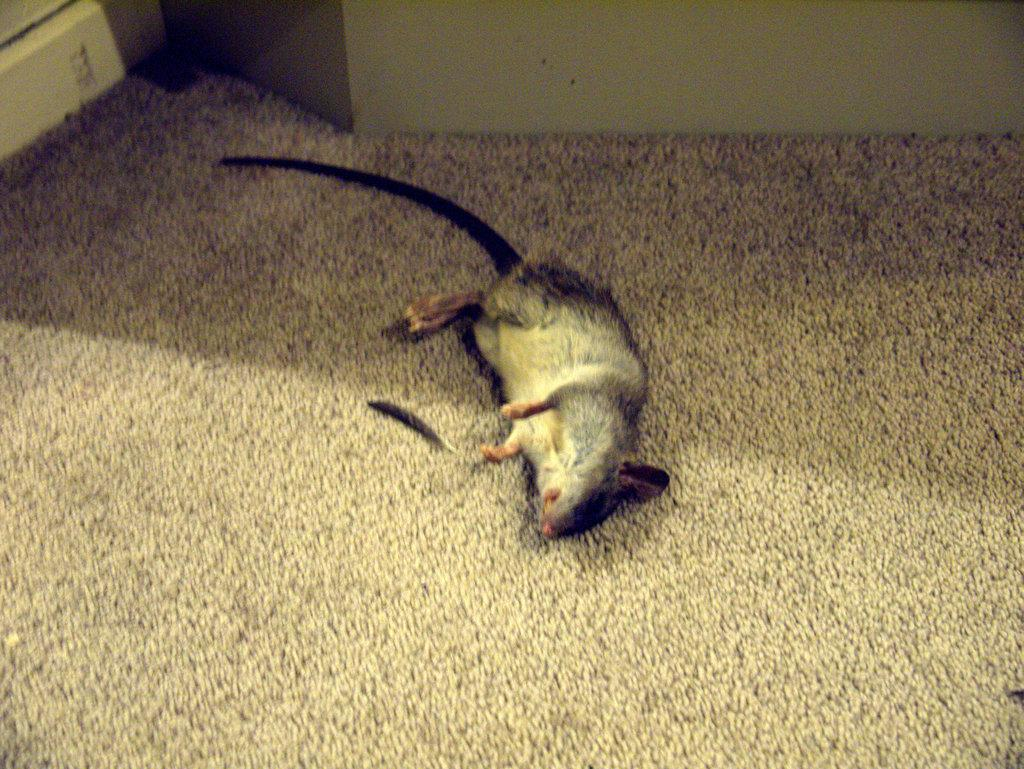What animal is in the picture? There is a mouse in the picture. What position is the mouse in? The mouse is lying on the ground. What can be seen in the background of the picture? There is a wall in the background of the picture. What type of cream is the mouse using to taste the wall in the image? There is no cream present in the image, and the mouse is not tasting the wall. 